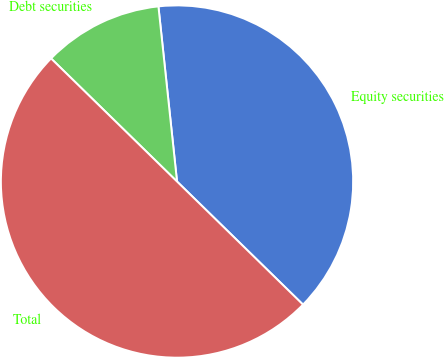<chart> <loc_0><loc_0><loc_500><loc_500><pie_chart><fcel>Equity securities<fcel>Debt securities<fcel>Total<nl><fcel>39.0%<fcel>11.0%<fcel>50.0%<nl></chart> 